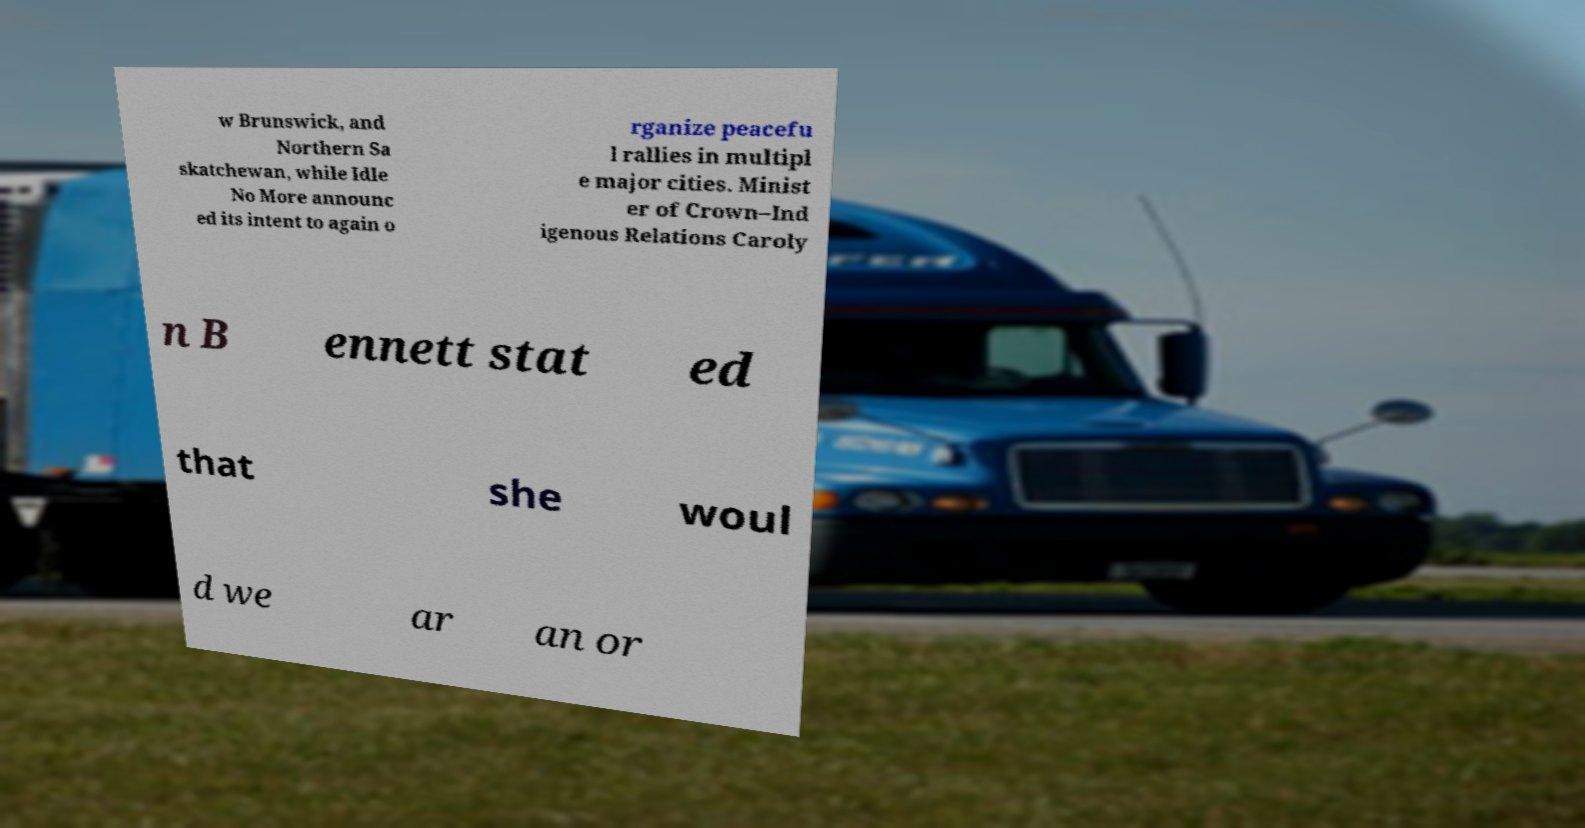Could you assist in decoding the text presented in this image and type it out clearly? w Brunswick, and Northern Sa skatchewan, while Idle No More announc ed its intent to again o rganize peacefu l rallies in multipl e major cities. Minist er of Crown–Ind igenous Relations Caroly n B ennett stat ed that she woul d we ar an or 